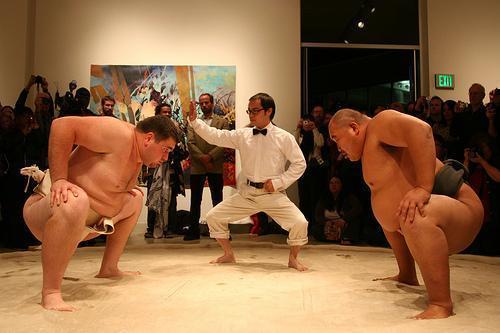How many sumo wrestlers are there?
Give a very brief answer. 2. 